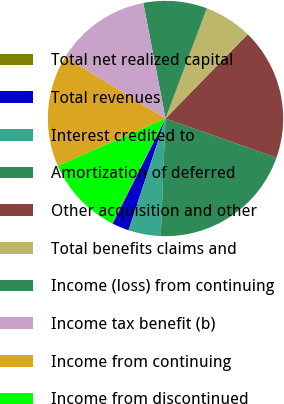Convert chart. <chart><loc_0><loc_0><loc_500><loc_500><pie_chart><fcel>Total net realized capital<fcel>Total revenues<fcel>Interest credited to<fcel>Amortization of deferred<fcel>Other acquisition and other<fcel>Total benefits claims and<fcel>Income (loss) from continuing<fcel>Income tax benefit (b)<fcel>Income from continuing<fcel>Income from discontinued<nl><fcel>0.15%<fcel>2.3%<fcel>4.44%<fcel>20.25%<fcel>18.1%<fcel>6.59%<fcel>8.73%<fcel>13.21%<fcel>15.36%<fcel>10.87%<nl></chart> 